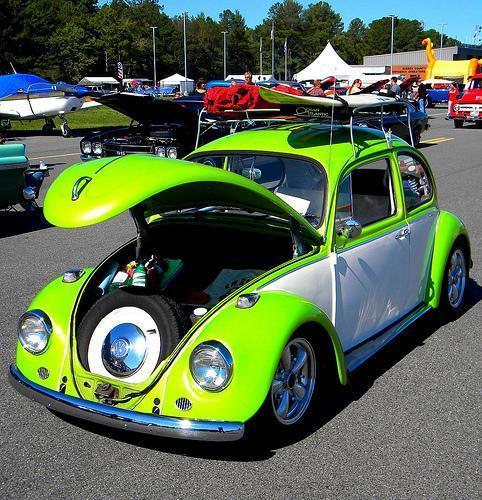How many of these vehicles are airplanes?
Give a very brief answer. 1. 